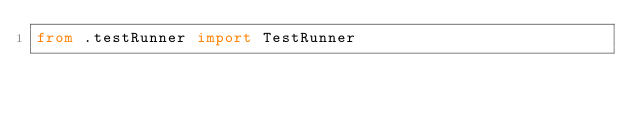<code> <loc_0><loc_0><loc_500><loc_500><_Python_>from .testRunner import TestRunner
</code> 